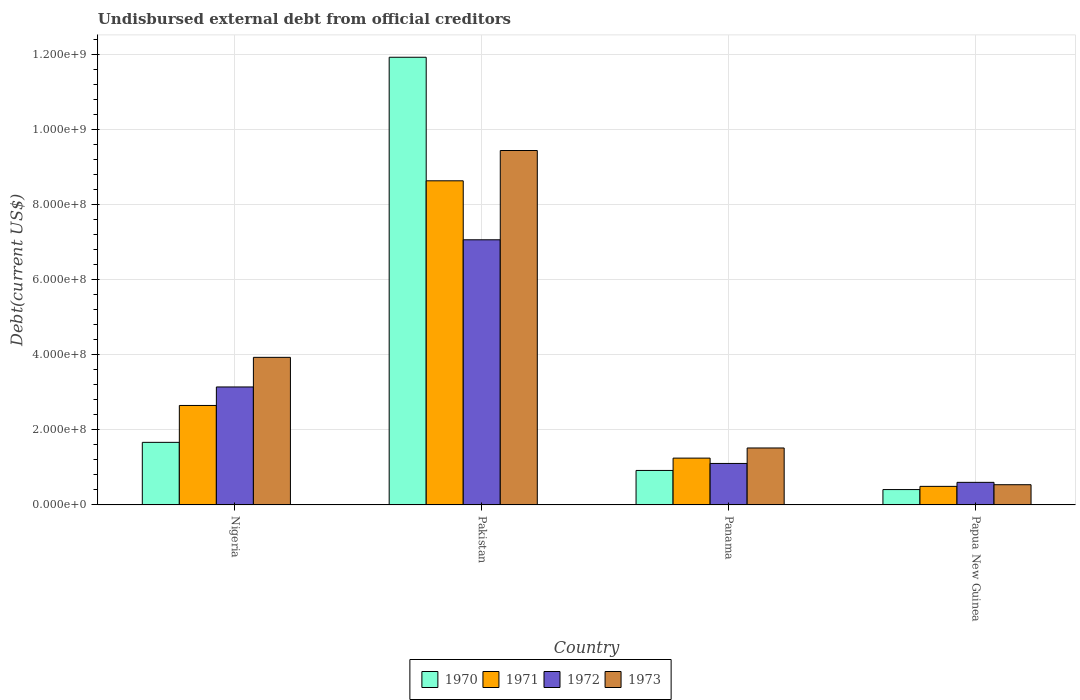How many different coloured bars are there?
Provide a short and direct response. 4. How many groups of bars are there?
Provide a succinct answer. 4. How many bars are there on the 1st tick from the right?
Your answer should be compact. 4. What is the label of the 1st group of bars from the left?
Keep it short and to the point. Nigeria. What is the total debt in 1973 in Papua New Guinea?
Make the answer very short. 5.39e+07. Across all countries, what is the maximum total debt in 1972?
Keep it short and to the point. 7.07e+08. Across all countries, what is the minimum total debt in 1970?
Give a very brief answer. 4.09e+07. In which country was the total debt in 1970 maximum?
Provide a short and direct response. Pakistan. In which country was the total debt in 1973 minimum?
Ensure brevity in your answer.  Papua New Guinea. What is the total total debt in 1973 in the graph?
Make the answer very short. 1.54e+09. What is the difference between the total debt in 1970 in Pakistan and that in Panama?
Offer a very short reply. 1.10e+09. What is the difference between the total debt in 1971 in Pakistan and the total debt in 1972 in Papua New Guinea?
Make the answer very short. 8.04e+08. What is the average total debt in 1970 per country?
Keep it short and to the point. 3.73e+08. What is the difference between the total debt of/in 1970 and total debt of/in 1973 in Pakistan?
Provide a succinct answer. 2.49e+08. What is the ratio of the total debt in 1971 in Nigeria to that in Papua New Guinea?
Offer a very short reply. 5.36. Is the total debt in 1972 in Nigeria less than that in Pakistan?
Ensure brevity in your answer.  Yes. Is the difference between the total debt in 1970 in Panama and Papua New Guinea greater than the difference between the total debt in 1973 in Panama and Papua New Guinea?
Provide a succinct answer. No. What is the difference between the highest and the second highest total debt in 1972?
Provide a succinct answer. 3.92e+08. What is the difference between the highest and the lowest total debt in 1971?
Make the answer very short. 8.14e+08. Is the sum of the total debt in 1972 in Nigeria and Panama greater than the maximum total debt in 1971 across all countries?
Ensure brevity in your answer.  No. Is it the case that in every country, the sum of the total debt in 1970 and total debt in 1973 is greater than the sum of total debt in 1972 and total debt in 1971?
Provide a short and direct response. No. What does the 3rd bar from the right in Pakistan represents?
Your response must be concise. 1971. How many countries are there in the graph?
Make the answer very short. 4. What is the difference between two consecutive major ticks on the Y-axis?
Your answer should be very brief. 2.00e+08. Where does the legend appear in the graph?
Keep it short and to the point. Bottom center. How are the legend labels stacked?
Offer a very short reply. Horizontal. What is the title of the graph?
Your answer should be compact. Undisbursed external debt from official creditors. Does "2003" appear as one of the legend labels in the graph?
Offer a terse response. No. What is the label or title of the Y-axis?
Keep it short and to the point. Debt(current US$). What is the Debt(current US$) in 1970 in Nigeria?
Make the answer very short. 1.67e+08. What is the Debt(current US$) in 1971 in Nigeria?
Your response must be concise. 2.65e+08. What is the Debt(current US$) in 1972 in Nigeria?
Your answer should be very brief. 3.14e+08. What is the Debt(current US$) of 1973 in Nigeria?
Make the answer very short. 3.93e+08. What is the Debt(current US$) of 1970 in Pakistan?
Your answer should be very brief. 1.19e+09. What is the Debt(current US$) in 1971 in Pakistan?
Your answer should be very brief. 8.64e+08. What is the Debt(current US$) of 1972 in Pakistan?
Your answer should be compact. 7.07e+08. What is the Debt(current US$) of 1973 in Pakistan?
Make the answer very short. 9.44e+08. What is the Debt(current US$) of 1970 in Panama?
Your response must be concise. 9.19e+07. What is the Debt(current US$) of 1971 in Panama?
Offer a terse response. 1.25e+08. What is the Debt(current US$) of 1972 in Panama?
Provide a short and direct response. 1.11e+08. What is the Debt(current US$) of 1973 in Panama?
Provide a short and direct response. 1.52e+08. What is the Debt(current US$) of 1970 in Papua New Guinea?
Offer a very short reply. 4.09e+07. What is the Debt(current US$) of 1971 in Papua New Guinea?
Provide a short and direct response. 4.95e+07. What is the Debt(current US$) in 1972 in Papua New Guinea?
Offer a terse response. 6.02e+07. What is the Debt(current US$) in 1973 in Papua New Guinea?
Offer a very short reply. 5.39e+07. Across all countries, what is the maximum Debt(current US$) in 1970?
Make the answer very short. 1.19e+09. Across all countries, what is the maximum Debt(current US$) in 1971?
Your response must be concise. 8.64e+08. Across all countries, what is the maximum Debt(current US$) in 1972?
Your answer should be very brief. 7.07e+08. Across all countries, what is the maximum Debt(current US$) in 1973?
Provide a short and direct response. 9.44e+08. Across all countries, what is the minimum Debt(current US$) in 1970?
Your response must be concise. 4.09e+07. Across all countries, what is the minimum Debt(current US$) of 1971?
Provide a short and direct response. 4.95e+07. Across all countries, what is the minimum Debt(current US$) of 1972?
Make the answer very short. 6.02e+07. Across all countries, what is the minimum Debt(current US$) of 1973?
Give a very brief answer. 5.39e+07. What is the total Debt(current US$) of 1970 in the graph?
Keep it short and to the point. 1.49e+09. What is the total Debt(current US$) in 1971 in the graph?
Offer a terse response. 1.30e+09. What is the total Debt(current US$) in 1972 in the graph?
Provide a short and direct response. 1.19e+09. What is the total Debt(current US$) in 1973 in the graph?
Offer a terse response. 1.54e+09. What is the difference between the Debt(current US$) of 1970 in Nigeria and that in Pakistan?
Provide a succinct answer. -1.03e+09. What is the difference between the Debt(current US$) in 1971 in Nigeria and that in Pakistan?
Offer a terse response. -5.99e+08. What is the difference between the Debt(current US$) in 1972 in Nigeria and that in Pakistan?
Your response must be concise. -3.92e+08. What is the difference between the Debt(current US$) of 1973 in Nigeria and that in Pakistan?
Offer a very short reply. -5.51e+08. What is the difference between the Debt(current US$) in 1970 in Nigeria and that in Panama?
Your response must be concise. 7.49e+07. What is the difference between the Debt(current US$) in 1971 in Nigeria and that in Panama?
Offer a very short reply. 1.40e+08. What is the difference between the Debt(current US$) of 1972 in Nigeria and that in Panama?
Provide a succinct answer. 2.04e+08. What is the difference between the Debt(current US$) in 1973 in Nigeria and that in Panama?
Offer a very short reply. 2.41e+08. What is the difference between the Debt(current US$) in 1970 in Nigeria and that in Papua New Guinea?
Your response must be concise. 1.26e+08. What is the difference between the Debt(current US$) in 1971 in Nigeria and that in Papua New Guinea?
Your response must be concise. 2.16e+08. What is the difference between the Debt(current US$) of 1972 in Nigeria and that in Papua New Guinea?
Provide a succinct answer. 2.54e+08. What is the difference between the Debt(current US$) in 1973 in Nigeria and that in Papua New Guinea?
Provide a succinct answer. 3.39e+08. What is the difference between the Debt(current US$) in 1970 in Pakistan and that in Panama?
Your answer should be very brief. 1.10e+09. What is the difference between the Debt(current US$) of 1971 in Pakistan and that in Panama?
Keep it short and to the point. 7.39e+08. What is the difference between the Debt(current US$) of 1972 in Pakistan and that in Panama?
Your answer should be very brief. 5.96e+08. What is the difference between the Debt(current US$) of 1973 in Pakistan and that in Panama?
Give a very brief answer. 7.93e+08. What is the difference between the Debt(current US$) in 1970 in Pakistan and that in Papua New Guinea?
Make the answer very short. 1.15e+09. What is the difference between the Debt(current US$) of 1971 in Pakistan and that in Papua New Guinea?
Offer a terse response. 8.14e+08. What is the difference between the Debt(current US$) of 1972 in Pakistan and that in Papua New Guinea?
Offer a very short reply. 6.46e+08. What is the difference between the Debt(current US$) of 1973 in Pakistan and that in Papua New Guinea?
Offer a terse response. 8.91e+08. What is the difference between the Debt(current US$) in 1970 in Panama and that in Papua New Guinea?
Keep it short and to the point. 5.10e+07. What is the difference between the Debt(current US$) in 1971 in Panama and that in Papua New Guinea?
Offer a terse response. 7.53e+07. What is the difference between the Debt(current US$) of 1972 in Panama and that in Papua New Guinea?
Offer a very short reply. 5.04e+07. What is the difference between the Debt(current US$) of 1973 in Panama and that in Papua New Guinea?
Offer a terse response. 9.79e+07. What is the difference between the Debt(current US$) in 1970 in Nigeria and the Debt(current US$) in 1971 in Pakistan?
Offer a very short reply. -6.97e+08. What is the difference between the Debt(current US$) of 1970 in Nigeria and the Debt(current US$) of 1972 in Pakistan?
Ensure brevity in your answer.  -5.40e+08. What is the difference between the Debt(current US$) of 1970 in Nigeria and the Debt(current US$) of 1973 in Pakistan?
Give a very brief answer. -7.78e+08. What is the difference between the Debt(current US$) in 1971 in Nigeria and the Debt(current US$) in 1972 in Pakistan?
Make the answer very short. -4.42e+08. What is the difference between the Debt(current US$) of 1971 in Nigeria and the Debt(current US$) of 1973 in Pakistan?
Give a very brief answer. -6.79e+08. What is the difference between the Debt(current US$) in 1972 in Nigeria and the Debt(current US$) in 1973 in Pakistan?
Provide a short and direct response. -6.30e+08. What is the difference between the Debt(current US$) of 1970 in Nigeria and the Debt(current US$) of 1971 in Panama?
Provide a succinct answer. 4.20e+07. What is the difference between the Debt(current US$) in 1970 in Nigeria and the Debt(current US$) in 1972 in Panama?
Your answer should be very brief. 5.62e+07. What is the difference between the Debt(current US$) in 1970 in Nigeria and the Debt(current US$) in 1973 in Panama?
Give a very brief answer. 1.50e+07. What is the difference between the Debt(current US$) of 1971 in Nigeria and the Debt(current US$) of 1972 in Panama?
Ensure brevity in your answer.  1.54e+08. What is the difference between the Debt(current US$) of 1971 in Nigeria and the Debt(current US$) of 1973 in Panama?
Offer a very short reply. 1.13e+08. What is the difference between the Debt(current US$) of 1972 in Nigeria and the Debt(current US$) of 1973 in Panama?
Make the answer very short. 1.63e+08. What is the difference between the Debt(current US$) in 1970 in Nigeria and the Debt(current US$) in 1971 in Papua New Guinea?
Offer a terse response. 1.17e+08. What is the difference between the Debt(current US$) in 1970 in Nigeria and the Debt(current US$) in 1972 in Papua New Guinea?
Ensure brevity in your answer.  1.07e+08. What is the difference between the Debt(current US$) of 1970 in Nigeria and the Debt(current US$) of 1973 in Papua New Guinea?
Provide a succinct answer. 1.13e+08. What is the difference between the Debt(current US$) of 1971 in Nigeria and the Debt(current US$) of 1972 in Papua New Guinea?
Offer a terse response. 2.05e+08. What is the difference between the Debt(current US$) in 1971 in Nigeria and the Debt(current US$) in 1973 in Papua New Guinea?
Your answer should be very brief. 2.11e+08. What is the difference between the Debt(current US$) in 1972 in Nigeria and the Debt(current US$) in 1973 in Papua New Guinea?
Keep it short and to the point. 2.61e+08. What is the difference between the Debt(current US$) in 1970 in Pakistan and the Debt(current US$) in 1971 in Panama?
Give a very brief answer. 1.07e+09. What is the difference between the Debt(current US$) of 1970 in Pakistan and the Debt(current US$) of 1972 in Panama?
Offer a terse response. 1.08e+09. What is the difference between the Debt(current US$) in 1970 in Pakistan and the Debt(current US$) in 1973 in Panama?
Offer a terse response. 1.04e+09. What is the difference between the Debt(current US$) in 1971 in Pakistan and the Debt(current US$) in 1972 in Panama?
Your answer should be very brief. 7.53e+08. What is the difference between the Debt(current US$) of 1971 in Pakistan and the Debt(current US$) of 1973 in Panama?
Your answer should be very brief. 7.12e+08. What is the difference between the Debt(current US$) in 1972 in Pakistan and the Debt(current US$) in 1973 in Panama?
Offer a very short reply. 5.55e+08. What is the difference between the Debt(current US$) in 1970 in Pakistan and the Debt(current US$) in 1971 in Papua New Guinea?
Your answer should be compact. 1.14e+09. What is the difference between the Debt(current US$) of 1970 in Pakistan and the Debt(current US$) of 1972 in Papua New Guinea?
Offer a terse response. 1.13e+09. What is the difference between the Debt(current US$) of 1970 in Pakistan and the Debt(current US$) of 1973 in Papua New Guinea?
Make the answer very short. 1.14e+09. What is the difference between the Debt(current US$) of 1971 in Pakistan and the Debt(current US$) of 1972 in Papua New Guinea?
Keep it short and to the point. 8.04e+08. What is the difference between the Debt(current US$) in 1971 in Pakistan and the Debt(current US$) in 1973 in Papua New Guinea?
Offer a very short reply. 8.10e+08. What is the difference between the Debt(current US$) of 1972 in Pakistan and the Debt(current US$) of 1973 in Papua New Guinea?
Keep it short and to the point. 6.53e+08. What is the difference between the Debt(current US$) in 1970 in Panama and the Debt(current US$) in 1971 in Papua New Guinea?
Offer a terse response. 4.24e+07. What is the difference between the Debt(current US$) of 1970 in Panama and the Debt(current US$) of 1972 in Papua New Guinea?
Offer a very short reply. 3.17e+07. What is the difference between the Debt(current US$) in 1970 in Panama and the Debt(current US$) in 1973 in Papua New Guinea?
Provide a succinct answer. 3.80e+07. What is the difference between the Debt(current US$) of 1971 in Panama and the Debt(current US$) of 1972 in Papua New Guinea?
Make the answer very short. 6.46e+07. What is the difference between the Debt(current US$) in 1971 in Panama and the Debt(current US$) in 1973 in Papua New Guinea?
Your answer should be compact. 7.09e+07. What is the difference between the Debt(current US$) in 1972 in Panama and the Debt(current US$) in 1973 in Papua New Guinea?
Offer a terse response. 5.67e+07. What is the average Debt(current US$) in 1970 per country?
Your answer should be very brief. 3.73e+08. What is the average Debt(current US$) in 1971 per country?
Make the answer very short. 3.26e+08. What is the average Debt(current US$) in 1972 per country?
Give a very brief answer. 2.98e+08. What is the average Debt(current US$) of 1973 per country?
Keep it short and to the point. 3.86e+08. What is the difference between the Debt(current US$) in 1970 and Debt(current US$) in 1971 in Nigeria?
Provide a succinct answer. -9.83e+07. What is the difference between the Debt(current US$) of 1970 and Debt(current US$) of 1972 in Nigeria?
Offer a terse response. -1.48e+08. What is the difference between the Debt(current US$) in 1970 and Debt(current US$) in 1973 in Nigeria?
Give a very brief answer. -2.27e+08. What is the difference between the Debt(current US$) in 1971 and Debt(current US$) in 1972 in Nigeria?
Ensure brevity in your answer.  -4.93e+07. What is the difference between the Debt(current US$) in 1971 and Debt(current US$) in 1973 in Nigeria?
Make the answer very short. -1.28e+08. What is the difference between the Debt(current US$) of 1972 and Debt(current US$) of 1973 in Nigeria?
Give a very brief answer. -7.89e+07. What is the difference between the Debt(current US$) in 1970 and Debt(current US$) in 1971 in Pakistan?
Ensure brevity in your answer.  3.29e+08. What is the difference between the Debt(current US$) in 1970 and Debt(current US$) in 1972 in Pakistan?
Offer a very short reply. 4.86e+08. What is the difference between the Debt(current US$) in 1970 and Debt(current US$) in 1973 in Pakistan?
Your response must be concise. 2.49e+08. What is the difference between the Debt(current US$) in 1971 and Debt(current US$) in 1972 in Pakistan?
Ensure brevity in your answer.  1.57e+08. What is the difference between the Debt(current US$) in 1971 and Debt(current US$) in 1973 in Pakistan?
Give a very brief answer. -8.07e+07. What is the difference between the Debt(current US$) in 1972 and Debt(current US$) in 1973 in Pakistan?
Offer a terse response. -2.38e+08. What is the difference between the Debt(current US$) in 1970 and Debt(current US$) in 1971 in Panama?
Provide a succinct answer. -3.29e+07. What is the difference between the Debt(current US$) of 1970 and Debt(current US$) of 1972 in Panama?
Give a very brief answer. -1.87e+07. What is the difference between the Debt(current US$) in 1970 and Debt(current US$) in 1973 in Panama?
Your response must be concise. -5.99e+07. What is the difference between the Debt(current US$) in 1971 and Debt(current US$) in 1972 in Panama?
Give a very brief answer. 1.42e+07. What is the difference between the Debt(current US$) of 1971 and Debt(current US$) of 1973 in Panama?
Your answer should be very brief. -2.70e+07. What is the difference between the Debt(current US$) of 1972 and Debt(current US$) of 1973 in Panama?
Your answer should be very brief. -4.12e+07. What is the difference between the Debt(current US$) in 1970 and Debt(current US$) in 1971 in Papua New Guinea?
Provide a succinct answer. -8.56e+06. What is the difference between the Debt(current US$) in 1970 and Debt(current US$) in 1972 in Papua New Guinea?
Provide a succinct answer. -1.93e+07. What is the difference between the Debt(current US$) of 1970 and Debt(current US$) of 1973 in Papua New Guinea?
Your answer should be very brief. -1.29e+07. What is the difference between the Debt(current US$) of 1971 and Debt(current US$) of 1972 in Papua New Guinea?
Provide a short and direct response. -1.07e+07. What is the difference between the Debt(current US$) of 1971 and Debt(current US$) of 1973 in Papua New Guinea?
Your response must be concise. -4.38e+06. What is the difference between the Debt(current US$) of 1972 and Debt(current US$) of 1973 in Papua New Guinea?
Your answer should be very brief. 6.30e+06. What is the ratio of the Debt(current US$) in 1970 in Nigeria to that in Pakistan?
Your answer should be compact. 0.14. What is the ratio of the Debt(current US$) in 1971 in Nigeria to that in Pakistan?
Give a very brief answer. 0.31. What is the ratio of the Debt(current US$) of 1972 in Nigeria to that in Pakistan?
Make the answer very short. 0.45. What is the ratio of the Debt(current US$) in 1973 in Nigeria to that in Pakistan?
Ensure brevity in your answer.  0.42. What is the ratio of the Debt(current US$) of 1970 in Nigeria to that in Panama?
Make the answer very short. 1.81. What is the ratio of the Debt(current US$) in 1971 in Nigeria to that in Panama?
Give a very brief answer. 2.12. What is the ratio of the Debt(current US$) in 1972 in Nigeria to that in Panama?
Offer a very short reply. 2.84. What is the ratio of the Debt(current US$) of 1973 in Nigeria to that in Panama?
Your response must be concise. 2.59. What is the ratio of the Debt(current US$) in 1970 in Nigeria to that in Papua New Guinea?
Offer a terse response. 4.07. What is the ratio of the Debt(current US$) in 1971 in Nigeria to that in Papua New Guinea?
Provide a short and direct response. 5.36. What is the ratio of the Debt(current US$) of 1972 in Nigeria to that in Papua New Guinea?
Ensure brevity in your answer.  5.22. What is the ratio of the Debt(current US$) in 1973 in Nigeria to that in Papua New Guinea?
Your answer should be very brief. 7.3. What is the ratio of the Debt(current US$) in 1970 in Pakistan to that in Panama?
Your response must be concise. 12.98. What is the ratio of the Debt(current US$) of 1971 in Pakistan to that in Panama?
Keep it short and to the point. 6.92. What is the ratio of the Debt(current US$) of 1972 in Pakistan to that in Panama?
Provide a short and direct response. 6.39. What is the ratio of the Debt(current US$) in 1973 in Pakistan to that in Panama?
Ensure brevity in your answer.  6.22. What is the ratio of the Debt(current US$) in 1970 in Pakistan to that in Papua New Guinea?
Keep it short and to the point. 29.15. What is the ratio of the Debt(current US$) of 1971 in Pakistan to that in Papua New Guinea?
Your response must be concise. 17.45. What is the ratio of the Debt(current US$) in 1972 in Pakistan to that in Papua New Guinea?
Keep it short and to the point. 11.74. What is the ratio of the Debt(current US$) of 1973 in Pakistan to that in Papua New Guinea?
Give a very brief answer. 17.53. What is the ratio of the Debt(current US$) in 1970 in Panama to that in Papua New Guinea?
Ensure brevity in your answer.  2.24. What is the ratio of the Debt(current US$) of 1971 in Panama to that in Papua New Guinea?
Your answer should be very brief. 2.52. What is the ratio of the Debt(current US$) in 1972 in Panama to that in Papua New Guinea?
Make the answer very short. 1.84. What is the ratio of the Debt(current US$) in 1973 in Panama to that in Papua New Guinea?
Provide a short and direct response. 2.82. What is the difference between the highest and the second highest Debt(current US$) in 1970?
Your response must be concise. 1.03e+09. What is the difference between the highest and the second highest Debt(current US$) in 1971?
Your response must be concise. 5.99e+08. What is the difference between the highest and the second highest Debt(current US$) in 1972?
Keep it short and to the point. 3.92e+08. What is the difference between the highest and the second highest Debt(current US$) of 1973?
Offer a very short reply. 5.51e+08. What is the difference between the highest and the lowest Debt(current US$) in 1970?
Provide a succinct answer. 1.15e+09. What is the difference between the highest and the lowest Debt(current US$) of 1971?
Provide a short and direct response. 8.14e+08. What is the difference between the highest and the lowest Debt(current US$) in 1972?
Your answer should be compact. 6.46e+08. What is the difference between the highest and the lowest Debt(current US$) of 1973?
Your answer should be compact. 8.91e+08. 